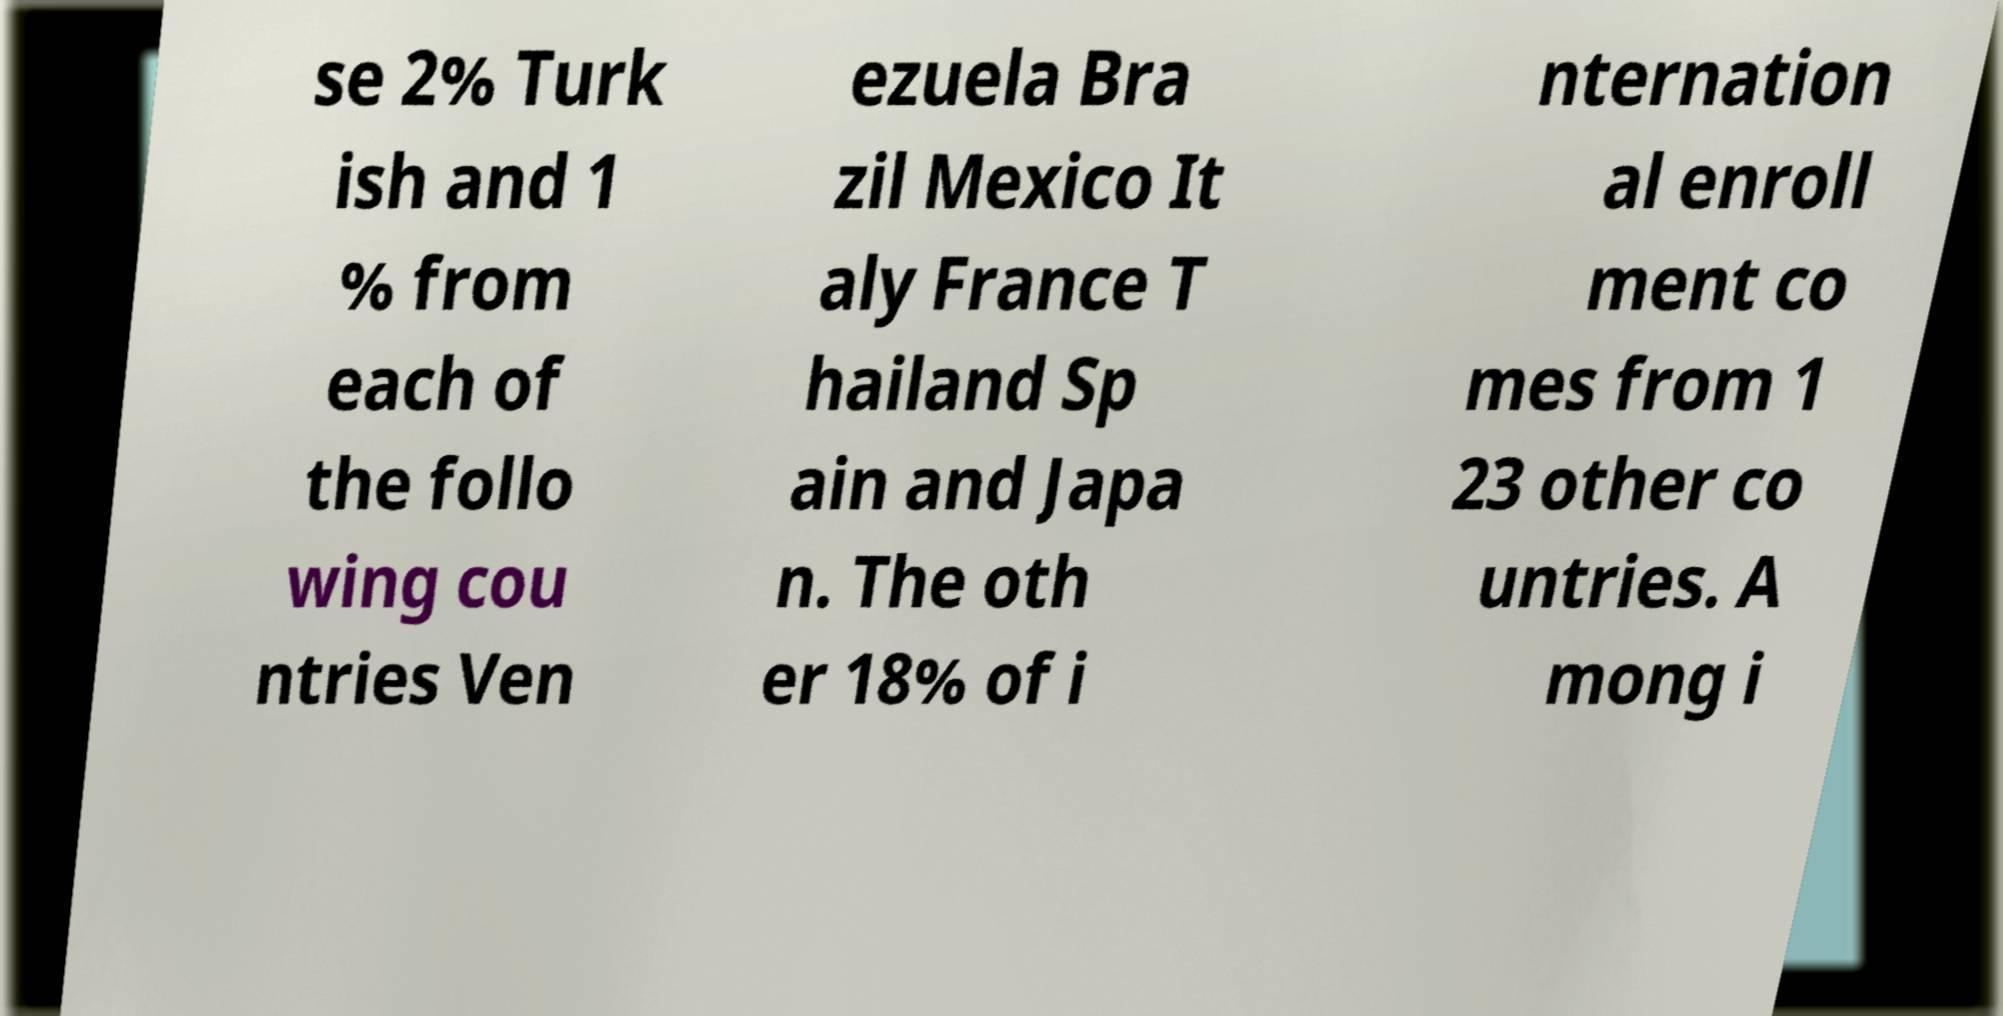Please read and relay the text visible in this image. What does it say? se 2% Turk ish and 1 % from each of the follo wing cou ntries Ven ezuela Bra zil Mexico It aly France T hailand Sp ain and Japa n. The oth er 18% of i nternation al enroll ment co mes from 1 23 other co untries. A mong i 